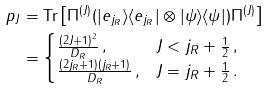Convert formula to latex. <formula><loc_0><loc_0><loc_500><loc_500>p _ { J } & = \text {Tr} \left [ \Pi ^ { ( J ) } ( | e _ { j _ { R } } \rangle \langle e _ { j _ { R } } | \otimes | \psi \rangle \langle \psi | ) \Pi ^ { ( J ) } \right ] \\ & = \begin{cases} \frac { ( 2 J + 1 ) ^ { 2 } } { D _ { R } } \, , & J < j _ { R } + \frac { 1 } { 2 } \, , \\ \frac { ( 2 j _ { R } + 1 ) ( j _ { R } + 1 ) } { D _ { R } } \, , & J = j _ { R } + \frac { 1 } { 2 } \, . \end{cases}</formula> 